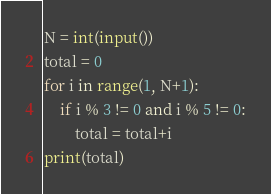<code> <loc_0><loc_0><loc_500><loc_500><_Python_>N = int(input())
total = 0
for i in range(1, N+1):
    if i % 3 != 0 and i % 5 != 0:
        total = total+i
print(total)</code> 